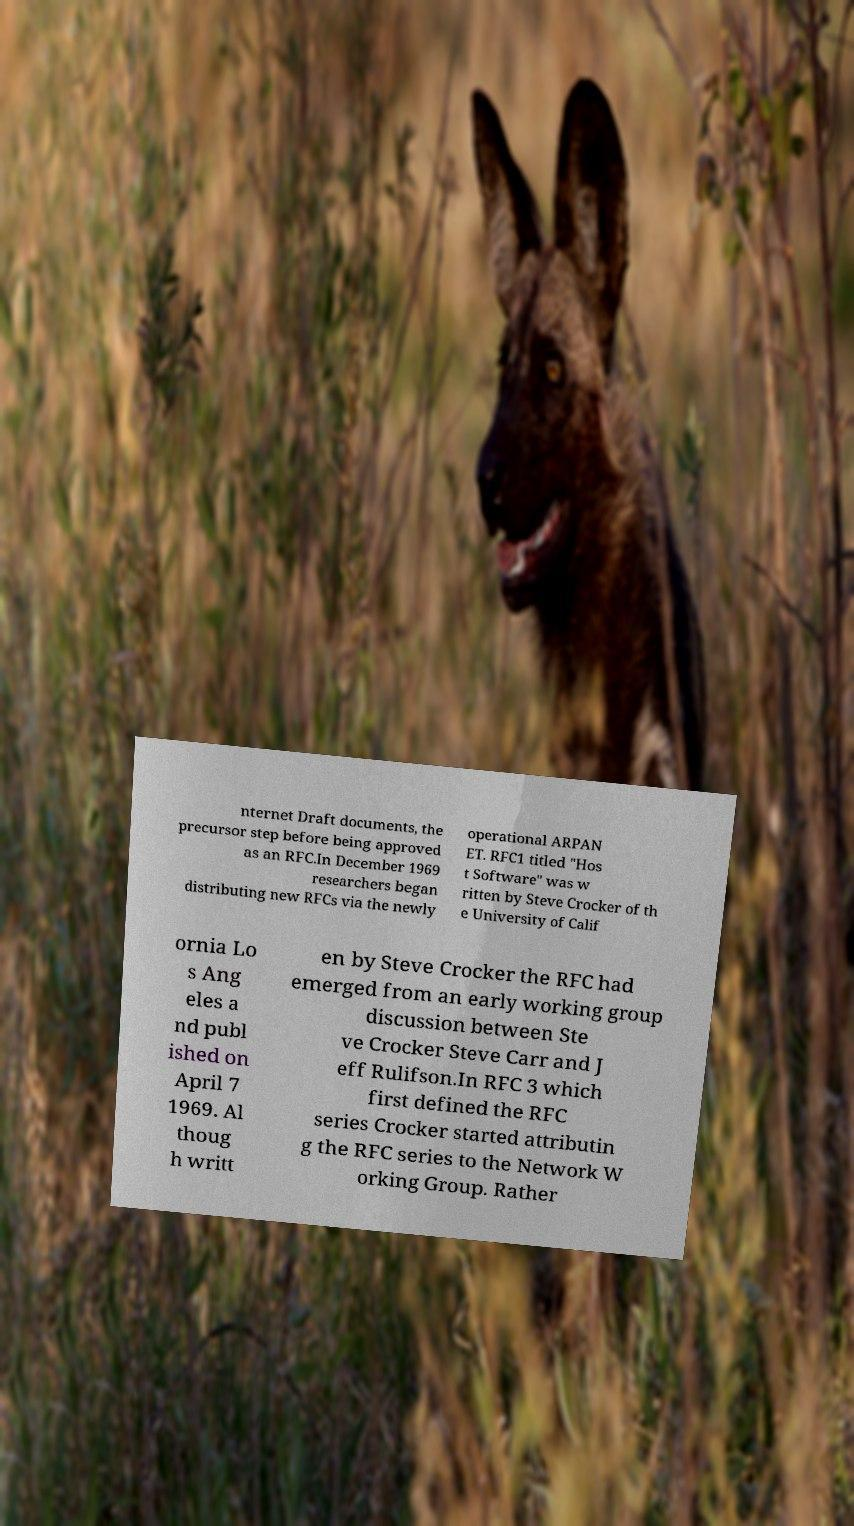There's text embedded in this image that I need extracted. Can you transcribe it verbatim? nternet Draft documents, the precursor step before being approved as an RFC.In December 1969 researchers began distributing new RFCs via the newly operational ARPAN ET. RFC1 titled "Hos t Software" was w ritten by Steve Crocker of th e University of Calif ornia Lo s Ang eles a nd publ ished on April 7 1969. Al thoug h writt en by Steve Crocker the RFC had emerged from an early working group discussion between Ste ve Crocker Steve Carr and J eff Rulifson.In RFC 3 which first defined the RFC series Crocker started attributin g the RFC series to the Network W orking Group. Rather 